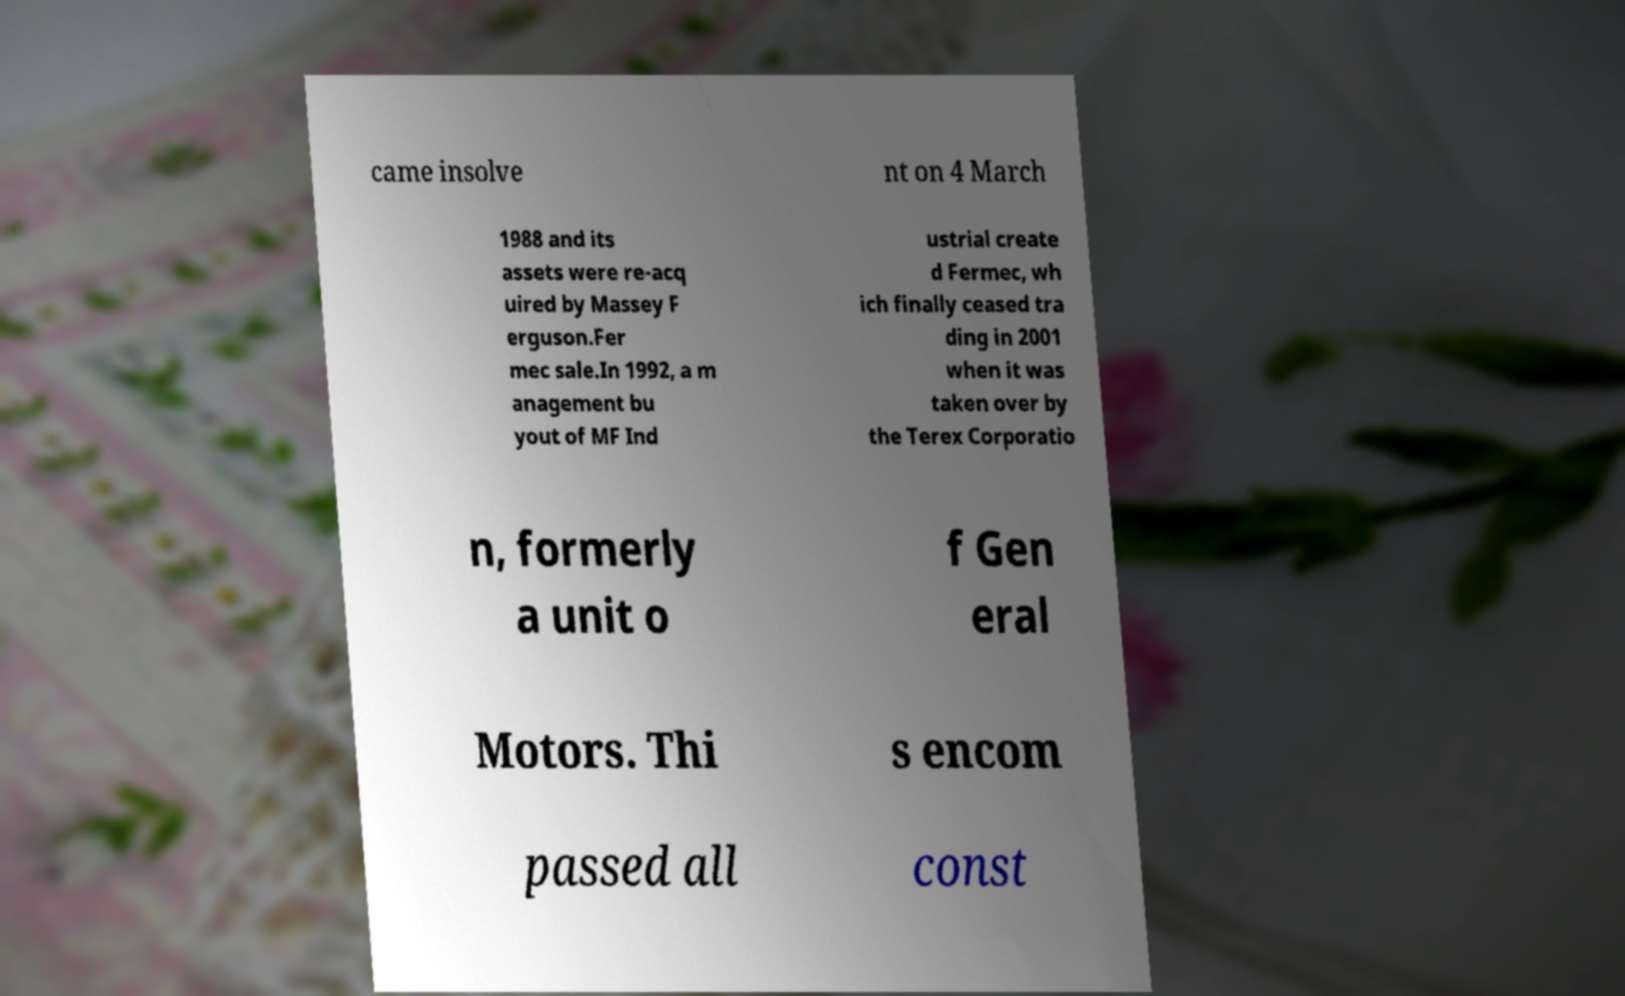Please read and relay the text visible in this image. What does it say? came insolve nt on 4 March 1988 and its assets were re-acq uired by Massey F erguson.Fer mec sale.In 1992, a m anagement bu yout of MF Ind ustrial create d Fermec, wh ich finally ceased tra ding in 2001 when it was taken over by the Terex Corporatio n, formerly a unit o f Gen eral Motors. Thi s encom passed all const 